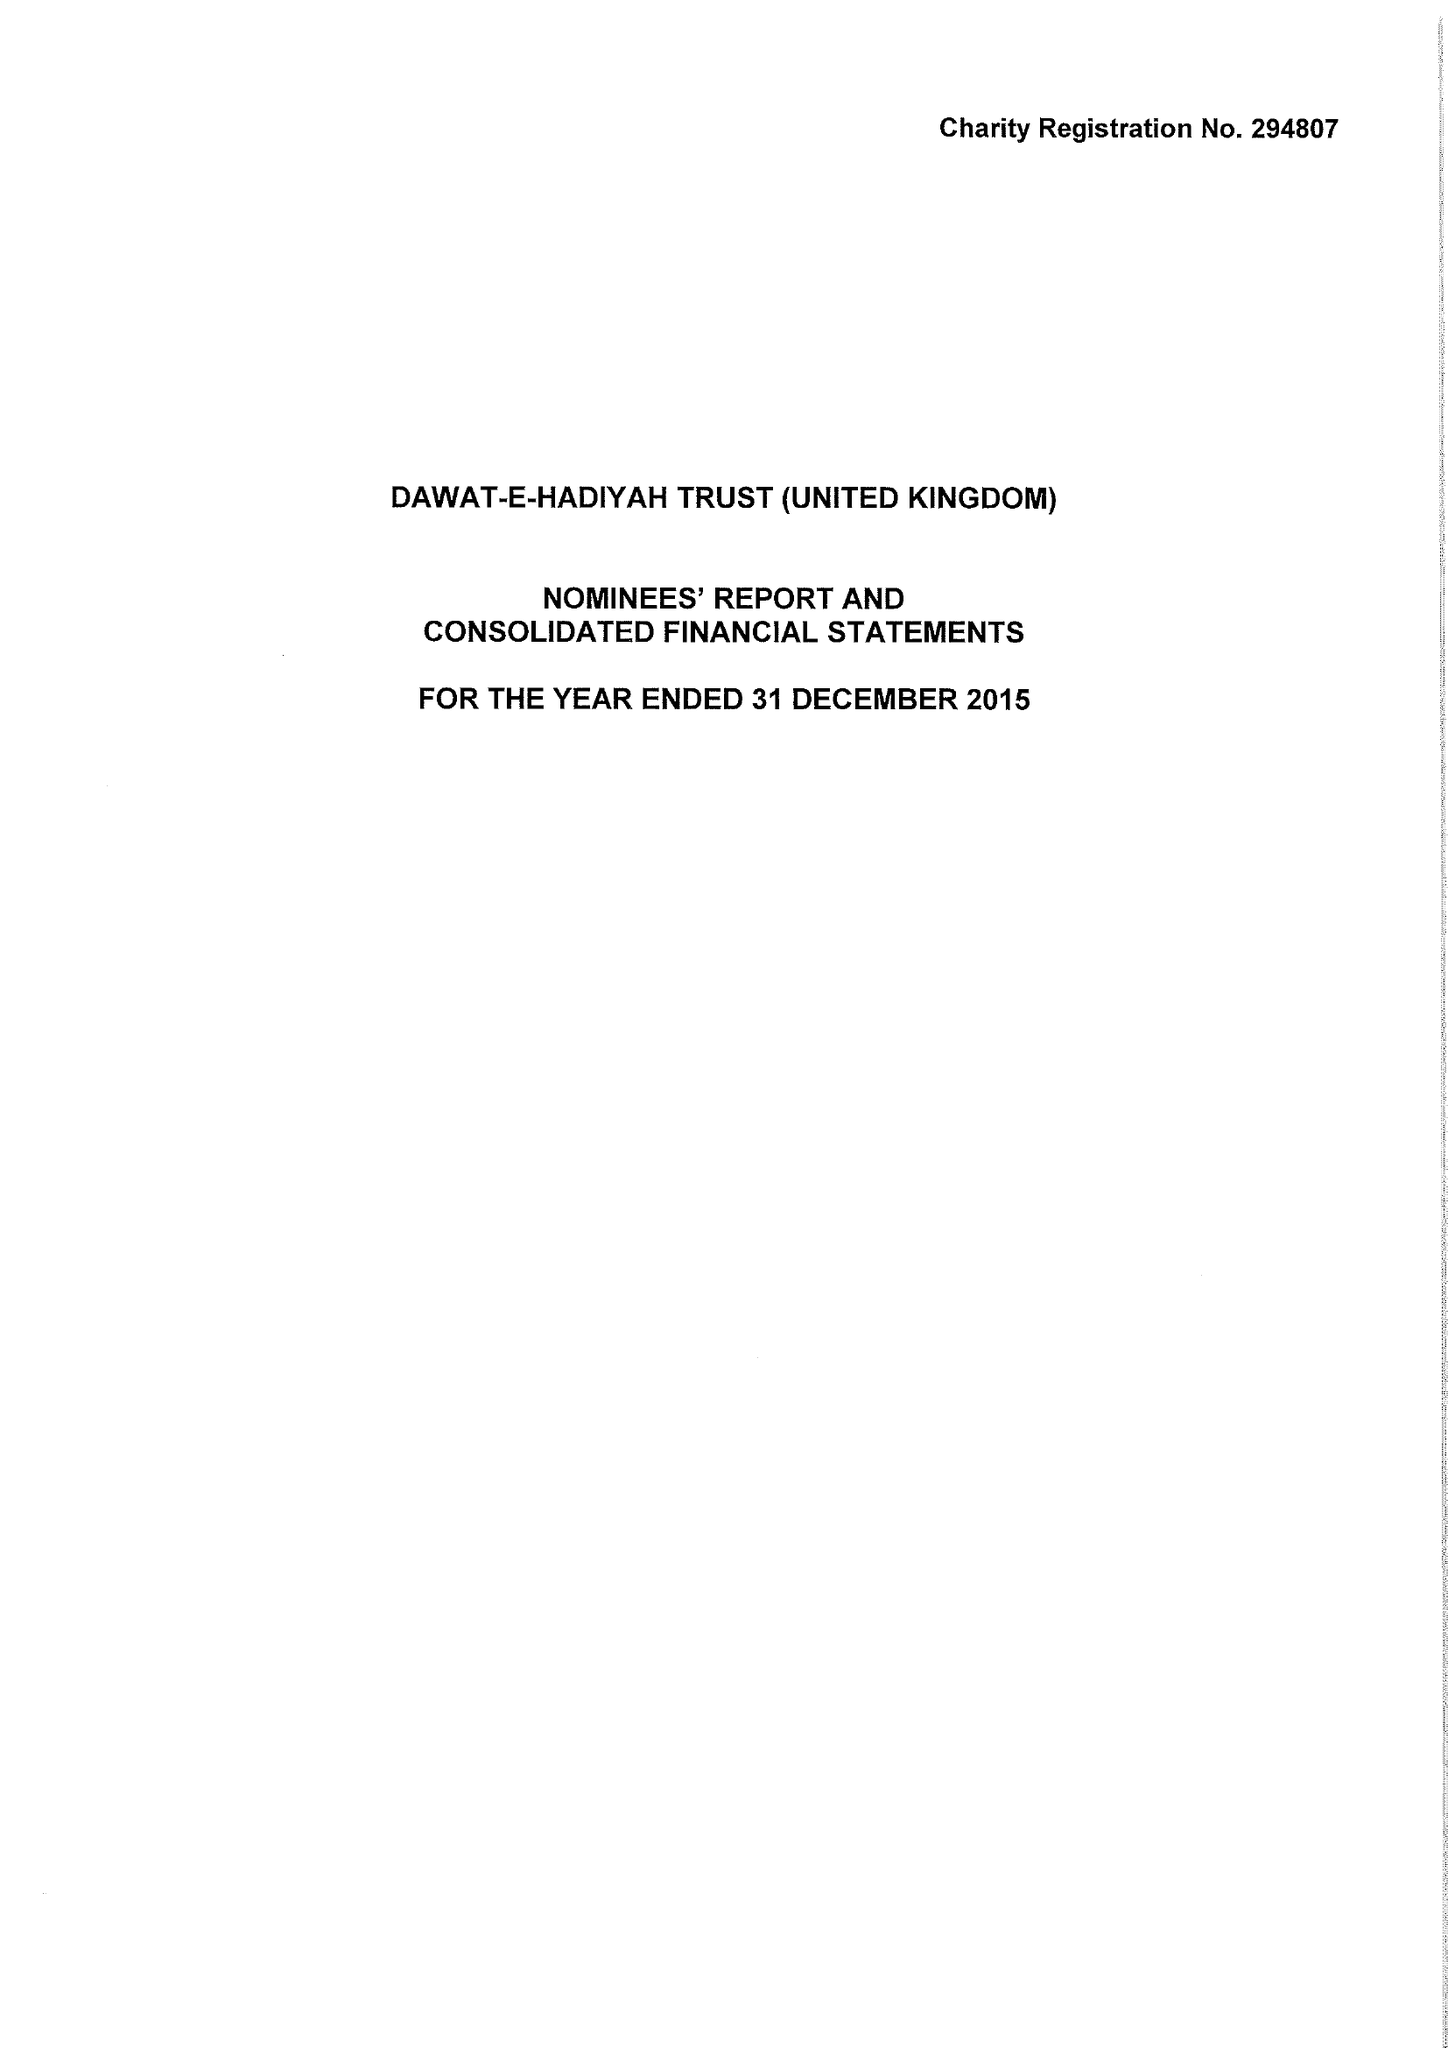What is the value for the income_annually_in_british_pounds?
Answer the question using a single word or phrase. 6560883.00 